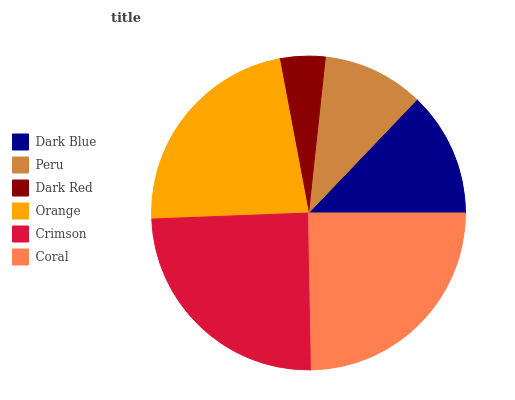Is Dark Red the minimum?
Answer yes or no. Yes. Is Coral the maximum?
Answer yes or no. Yes. Is Peru the minimum?
Answer yes or no. No. Is Peru the maximum?
Answer yes or no. No. Is Dark Blue greater than Peru?
Answer yes or no. Yes. Is Peru less than Dark Blue?
Answer yes or no. Yes. Is Peru greater than Dark Blue?
Answer yes or no. No. Is Dark Blue less than Peru?
Answer yes or no. No. Is Orange the high median?
Answer yes or no. Yes. Is Dark Blue the low median?
Answer yes or no. Yes. Is Dark Red the high median?
Answer yes or no. No. Is Crimson the low median?
Answer yes or no. No. 